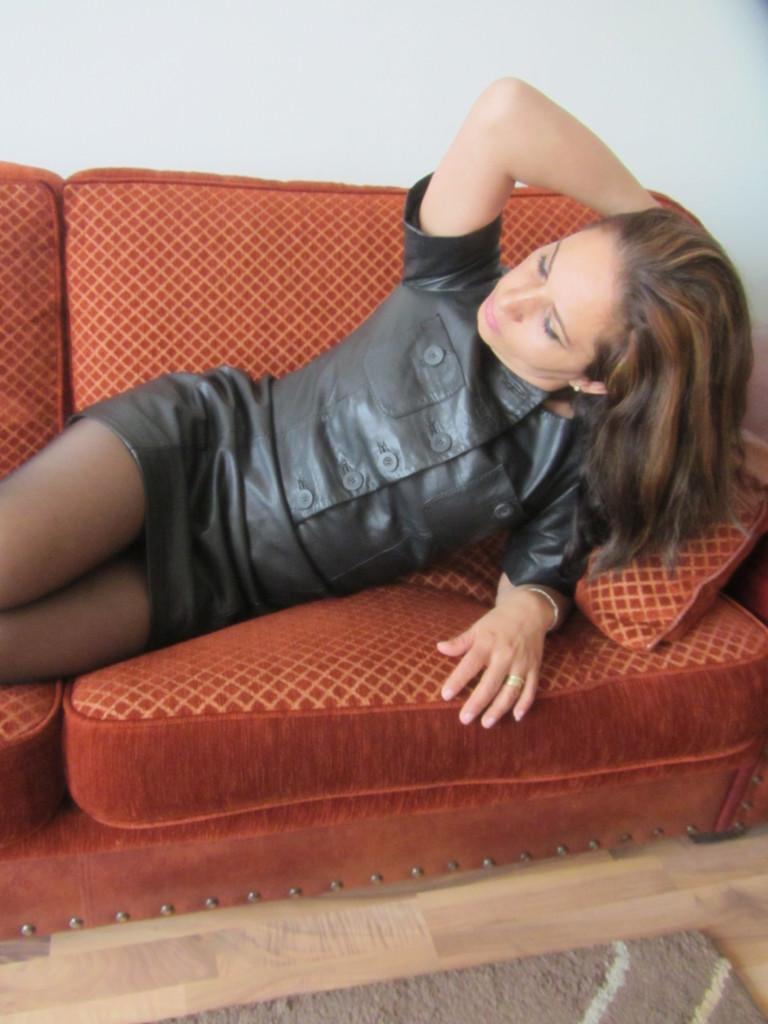Describe this image in one or two sentences. In this image we can see a woman lying on the sofa. In the background, we can see the wall. 